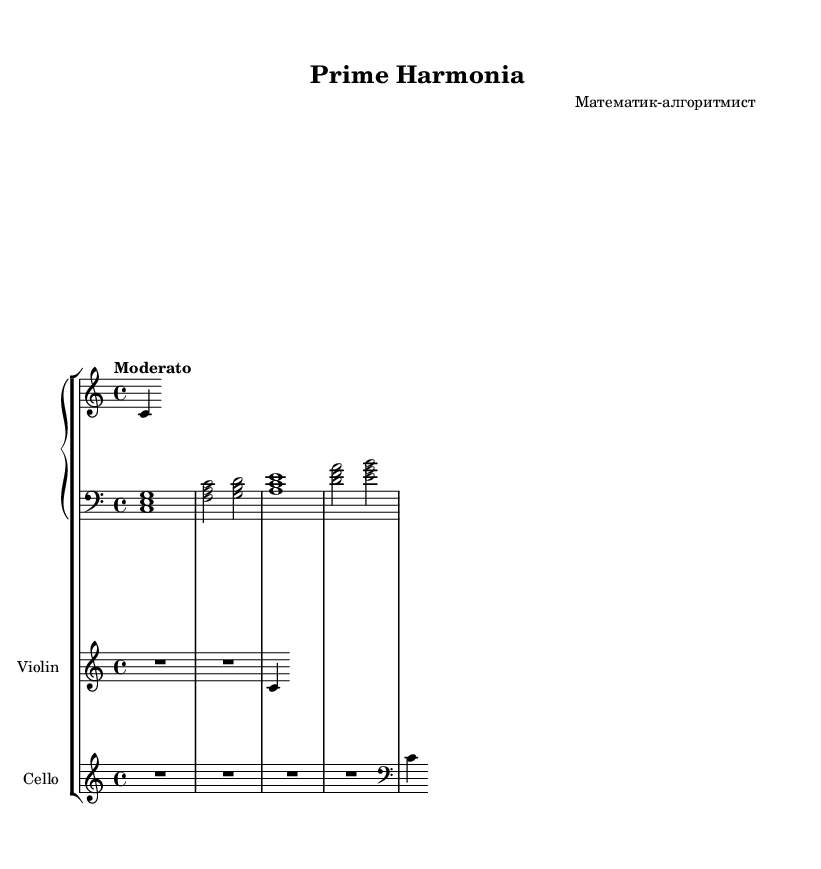What is the key signature of this music? The key signature is C major, which has no sharps or flats, indicated at the beginning of the staff.
Answer: C major What is the time signature of this music? The time signature is 4/4, which is indicated at the beginning of the score and represents a measure containing four beats.
Answer: 4/4 What is the tempo marking for this piece? The tempo marking is "Moderato," indicating a moderate speed, commonly found near the top of the score.
Answer: Moderato Which instruments are used in this composition? The instruments used are Piano, Violin, and Cello, as specified in the score where each staff is labeled with the respective instrument name.
Answer: Piano, Violin, Cello How many notes are generated by the prime number sequence in the melody? The prime number sequence consists of 10 prime numbers, which translates into 10 notes in the generated melody.
Answer: 10 What is the relative pitch used for the generated melody in the piano? The generated melody starts at the note C in the relative octave indicated, and transforms pitches based on the differences between consecutive numbers in the prime sequence modulated by 7.
Answer: C What rhythmic value is assigned to the left hand piano part? The rhythmic value assigned to the left hand piano part is whole and half notes, which are indicated by the note groupings such as <c e g>1, showing the duration of each chord.
Answer: Whole and half notes 